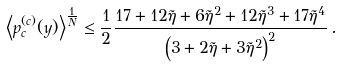Convert formula to latex. <formula><loc_0><loc_0><loc_500><loc_500>\left < p _ { c } ^ { ( c ) } ( y ) \right > ^ { \frac { 1 } { N } } \leq \frac { 1 } { 2 } \frac { 1 7 + 1 2 \tilde { \eta } + 6 \tilde { \eta } ^ { 2 } + 1 2 \tilde { \eta } ^ { 3 } + 1 7 \tilde { \eta } ^ { 4 } } { \left ( 3 + 2 \tilde { \eta } + 3 \tilde { \eta } ^ { 2 } \right ) ^ { 2 } } \, .</formula> 